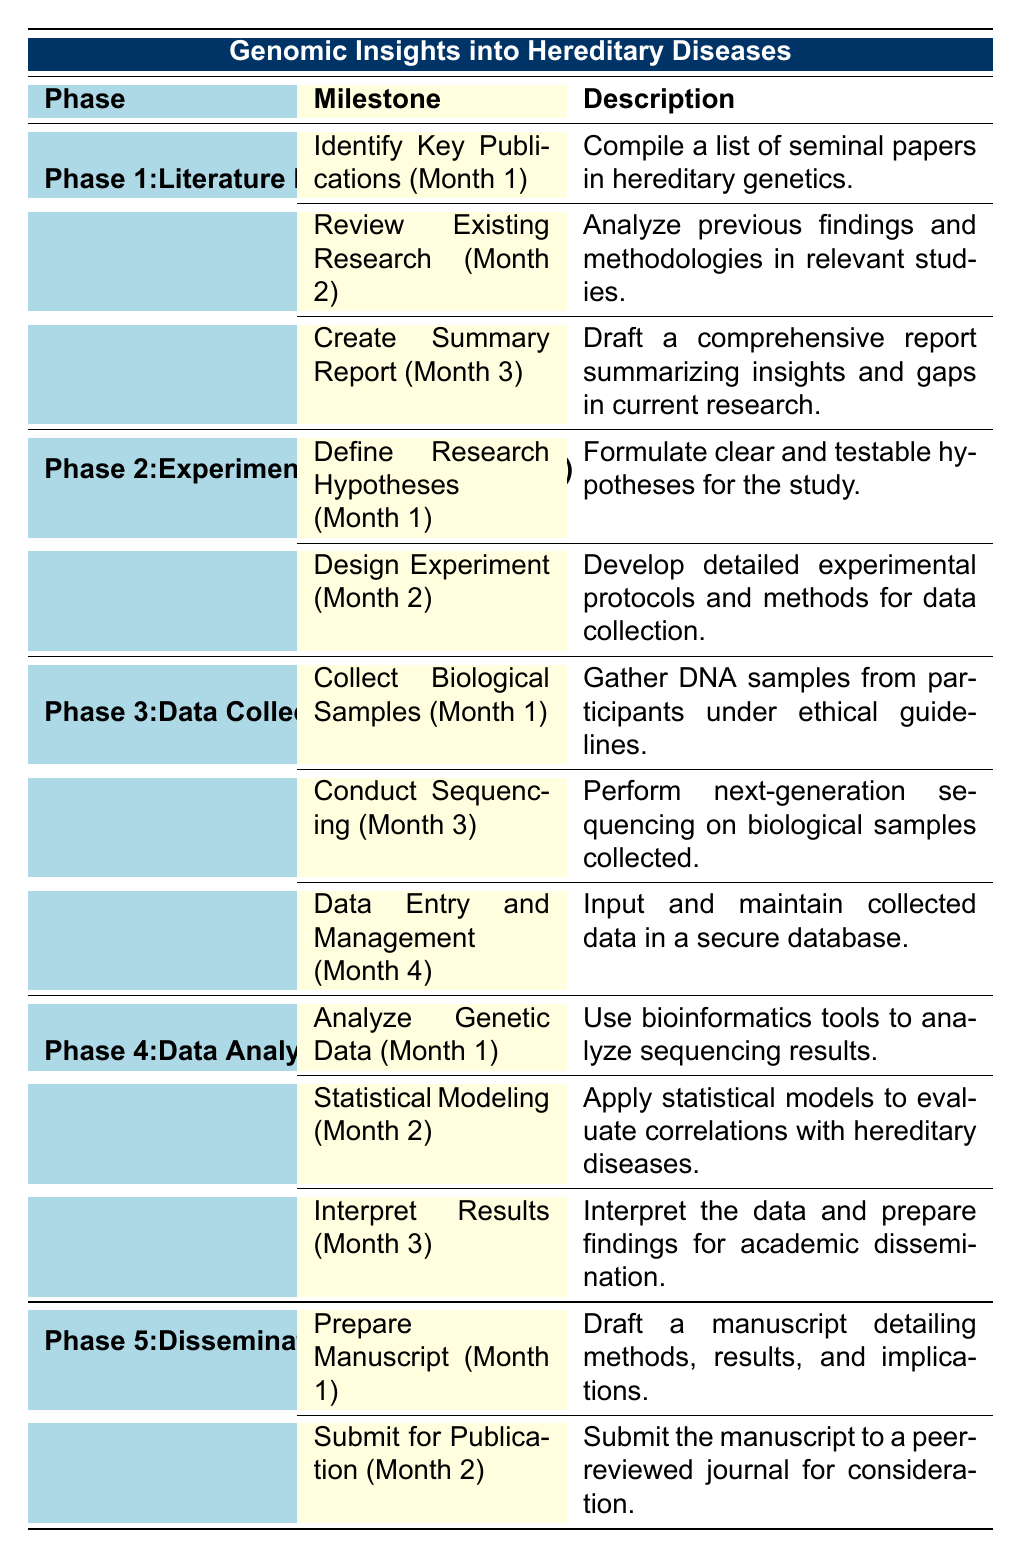What is the total duration of the entire project? To calculate the total duration, we add the durations of all five phases: Phase 1 (3 months) + Phase 2 (2 months) + Phase 3 (4 months) + Phase 4 (3 months) + Phase 5 (2 months) = 3 + 2 + 4 + 3 + 2 = 14 months.
Answer: 14 months Which milestone is scheduled for completion in Month 2? By reviewing the milestones in the table, "Review Existing Research" from Phase 1 and "Design Experiment" from Phase 2 are both scheduled for completion in Month 2.
Answer: Review Existing Research, Design Experiment How many milestones are there in Phase 3? There are three milestones listed under Phase 3: "Collect Biological Samples," "Conduct Sequencing," and "Data Entry and Management." Therefore, the total number of milestones in this phase is 3.
Answer: 3 Is there a milestone related to submitting the manuscript after preparation? The table indicates that after the "Prepare Manuscript" milestone in Month 1, the next milestone is "Submit for Publication" in Month 2. Therefore, there is indeed a milestone related to submission after preparation.
Answer: Yes What are the durations of the phases that involve data-related tasks? The phases involving data-related tasks are Phase 3 (Data Collection) lasting 4 months and Phase 4 (Data Analysis) lasting 3 months. Therefore, the total duration is 4 + 3 = 7 months.
Answer: 7 months 